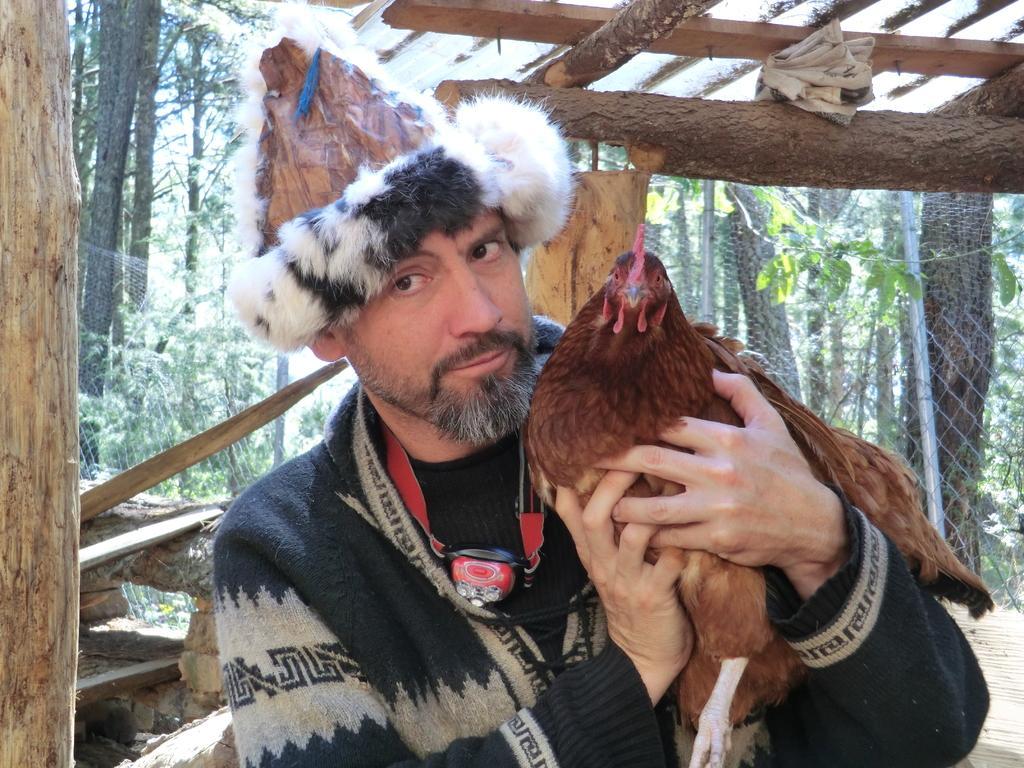Please provide a concise description of this image. In the front of the image I can see a person wearing a hat, an object and holding a hen. In the background of the image there are branches, mesh, pole and trees.   